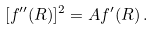Convert formula to latex. <formula><loc_0><loc_0><loc_500><loc_500>[ f ^ { \prime \prime } ( R ) ] ^ { 2 } = A f ^ { \prime } ( R ) \, .</formula> 